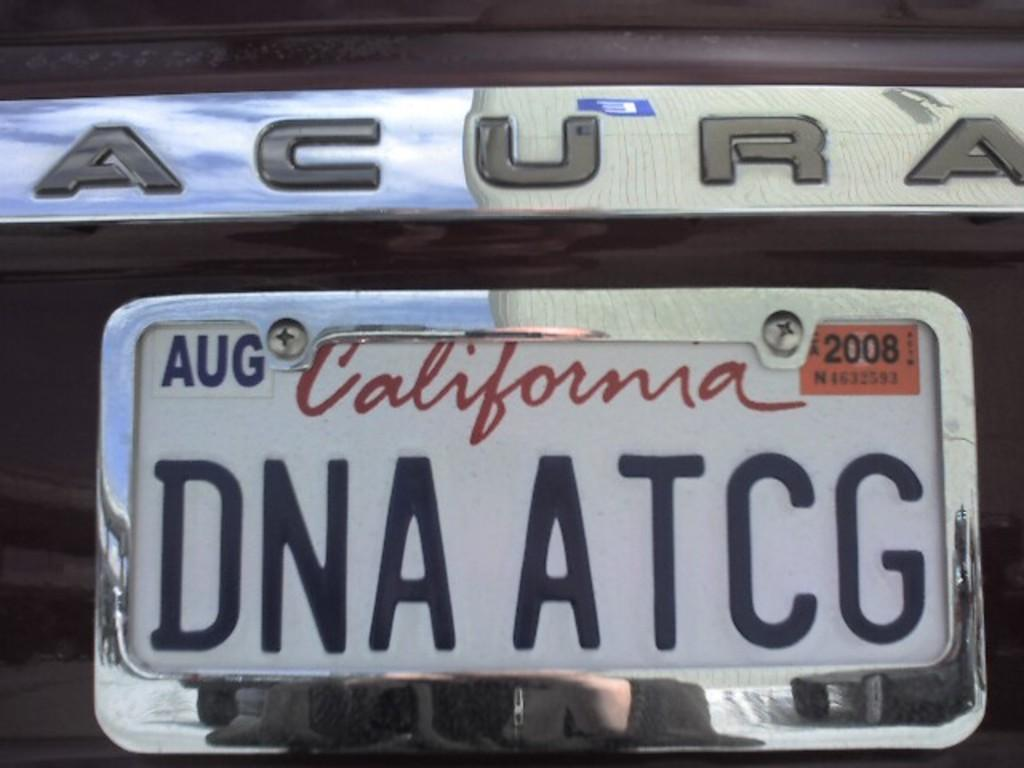Provide a one-sentence caption for the provided image. acura with AUG 2008 california tags DNA ATCG. 